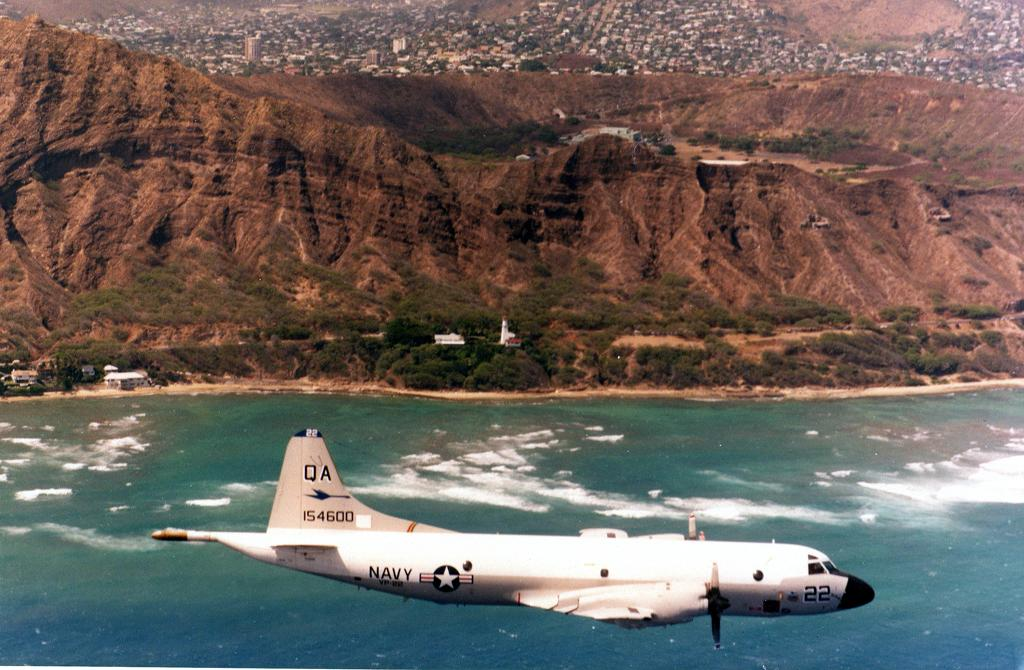<image>
Present a compact description of the photo's key features. a plane flying over the ocean with Navy on the side 